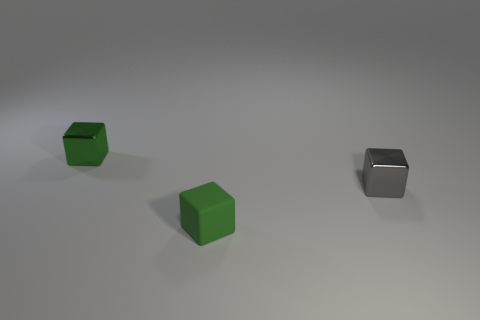How many things are either yellow cubes or cubes behind the green rubber object?
Offer a very short reply. 2. There is a block that is behind the tiny metal block that is right of the matte thing; what color is it?
Keep it short and to the point. Green. Is the color of the small cube that is left of the tiny rubber block the same as the small rubber cube?
Offer a terse response. Yes. What is the cube behind the tiny gray cube made of?
Your answer should be compact. Metal. Do the green cube behind the small gray block and the gray thing have the same material?
Your answer should be very brief. Yes. How many purple balls are there?
Your response must be concise. 0. What number of objects are tiny green matte things or cubes?
Provide a succinct answer. 3. How many small rubber blocks are right of the tiny green object that is right of the green object behind the green rubber cube?
Offer a very short reply. 0. Is there anything else that has the same color as the matte cube?
Keep it short and to the point. Yes. There is a metallic cube that is left of the green matte cube; is its color the same as the tiny object that is in front of the gray metal cube?
Make the answer very short. Yes. 